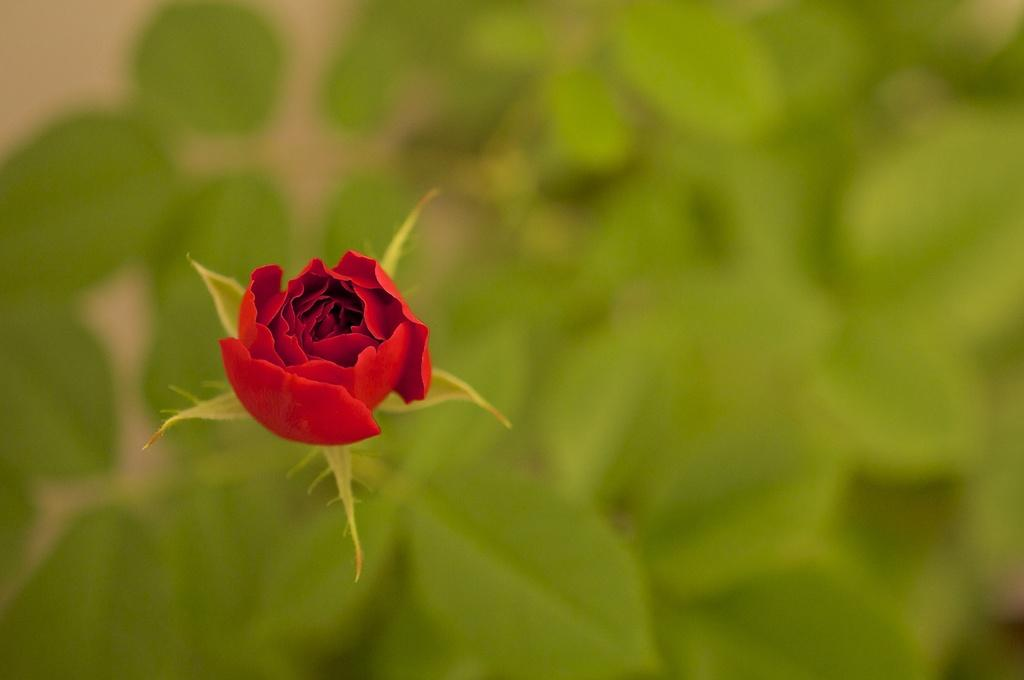What is the main subject of the image? There is a flower in the image. What color is the flower? The flower is red in color. What color are the petals of the flower? The petals of the flower are green in color. What can be seen in the background of the image? There is a tree in the background of the image. What color is the tree? The tree is green in color. What statement can be made about the straw in the image? There is no straw present in the image. How does the flower make sense in the context of the image? The flower is the main subject of the image, and its presence and color make sense in the context of the image. 